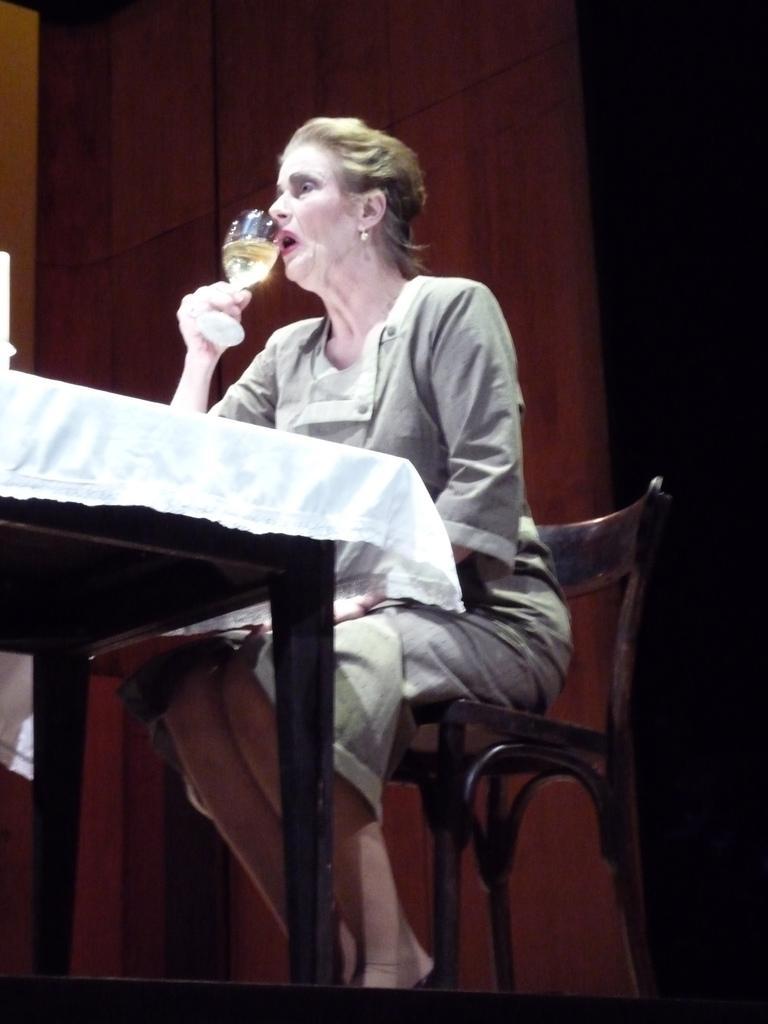In one or two sentences, can you explain what this image depicts? In the middle of the image a woman is sitting and holding a glass and drinking. Bottom left side of the image there is a table on the table there is a cloth. Behind her there is a wooden wall. 